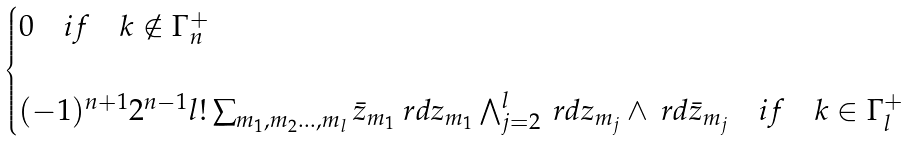<formula> <loc_0><loc_0><loc_500><loc_500>\begin{cases} 0 \quad i f \quad \mathbb { m } { k } \notin \Gamma _ { n } ^ { + } \\ \, \\ ( - 1 ) ^ { n + 1 } 2 ^ { n - 1 } l ! \sum _ { m _ { 1 } , m _ { 2 } \dots , m _ { l } } \bar { z } _ { m _ { 1 } } \ r d z _ { m _ { 1 } } \bigwedge _ { j = 2 } ^ { l } \ r d z _ { m _ { j } } \wedge \ r d \bar { z } _ { m _ { j } } \quad i f \quad \mathbb { m } { k } \in \Gamma _ { l } ^ { + } \\ \end{cases}</formula> 